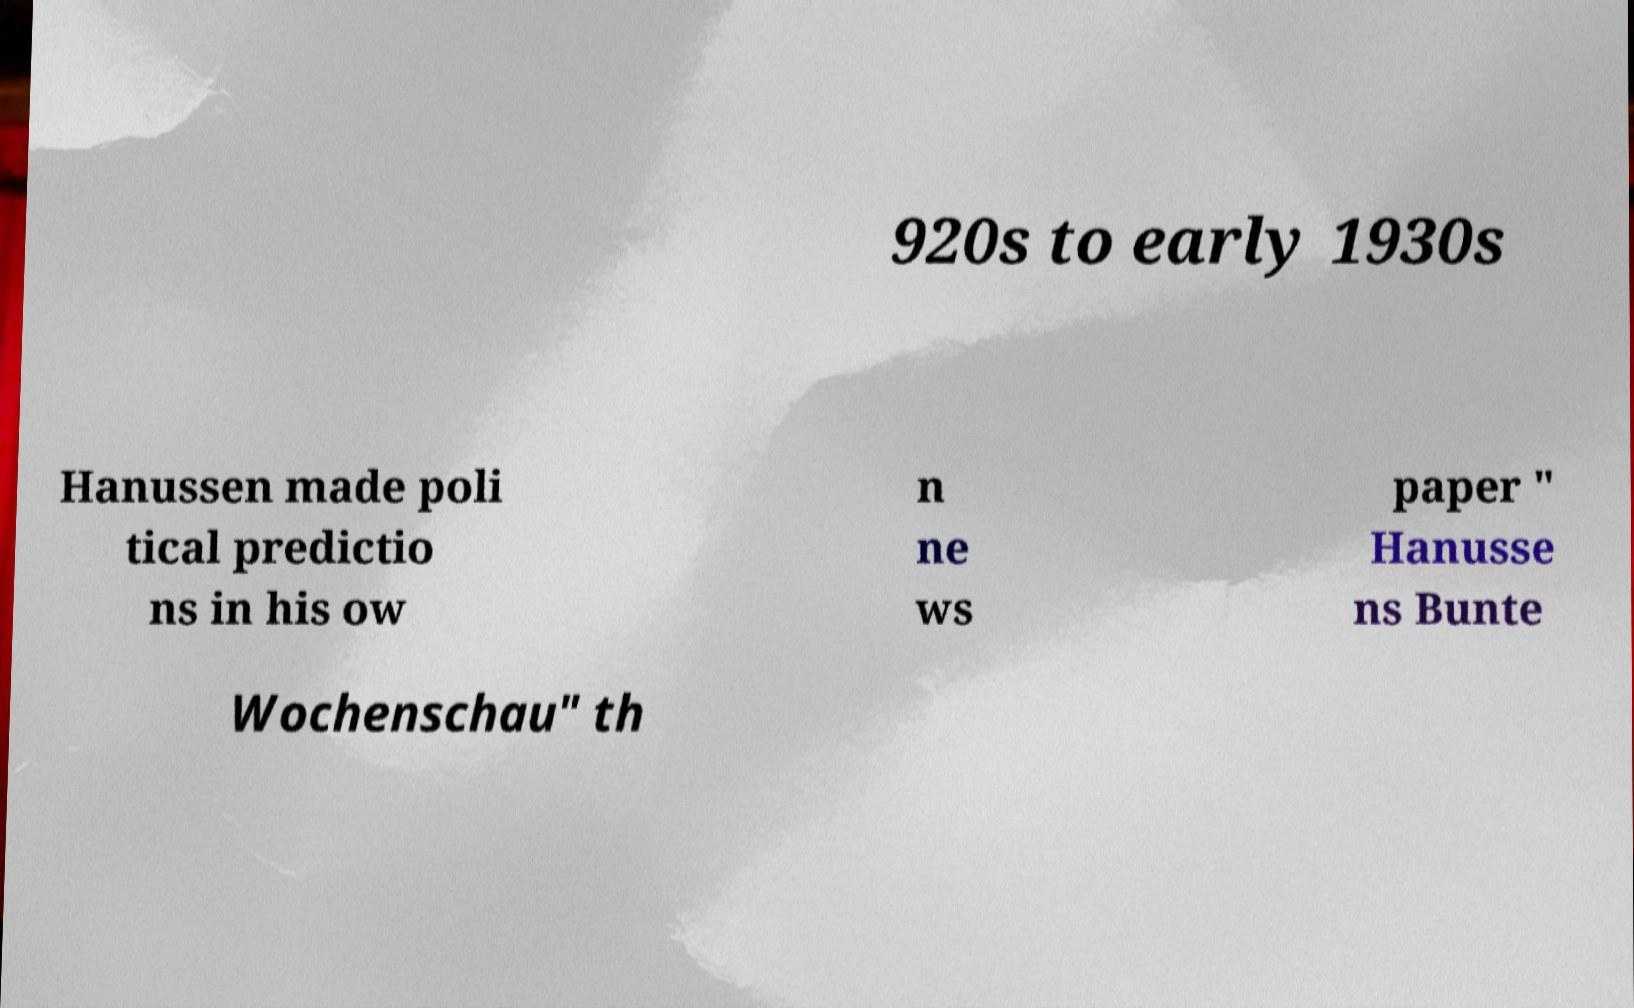Can you accurately transcribe the text from the provided image for me? 920s to early 1930s Hanussen made poli tical predictio ns in his ow n ne ws paper " Hanusse ns Bunte Wochenschau" th 